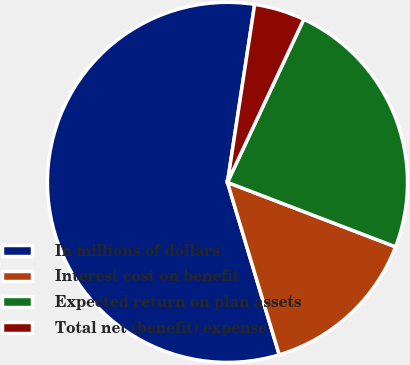Convert chart. <chart><loc_0><loc_0><loc_500><loc_500><pie_chart><fcel>In millions of dollars<fcel>Interest cost on benefit<fcel>Expected return on plan assets<fcel>Total net (benefit) expense<nl><fcel>57.05%<fcel>14.53%<fcel>23.86%<fcel>4.55%<nl></chart> 